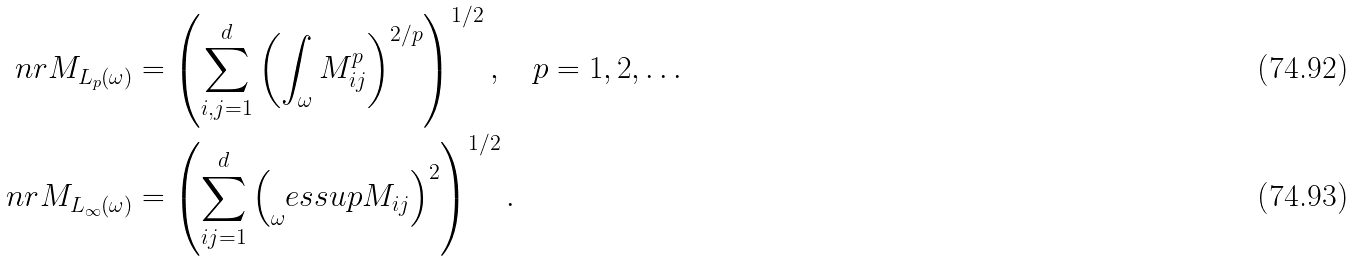<formula> <loc_0><loc_0><loc_500><loc_500>\ n r M _ { L _ { p } ( \omega ) } & = \left ( \sum _ { i , j = 1 } ^ { d } \left ( \int _ { \omega } M _ { i j } ^ { p } \right ) ^ { 2 / p } \right ) ^ { 1 / 2 } , \quad p = 1 , 2 , \dots \\ \ n r M _ { L _ { \infty } ( \omega ) } & = \left ( \sum _ { i j = 1 } ^ { d } \left ( \underset { \omega } \ e s s u p M _ { i j } \right ) ^ { 2 } \right ) ^ { 1 / 2 } .</formula> 